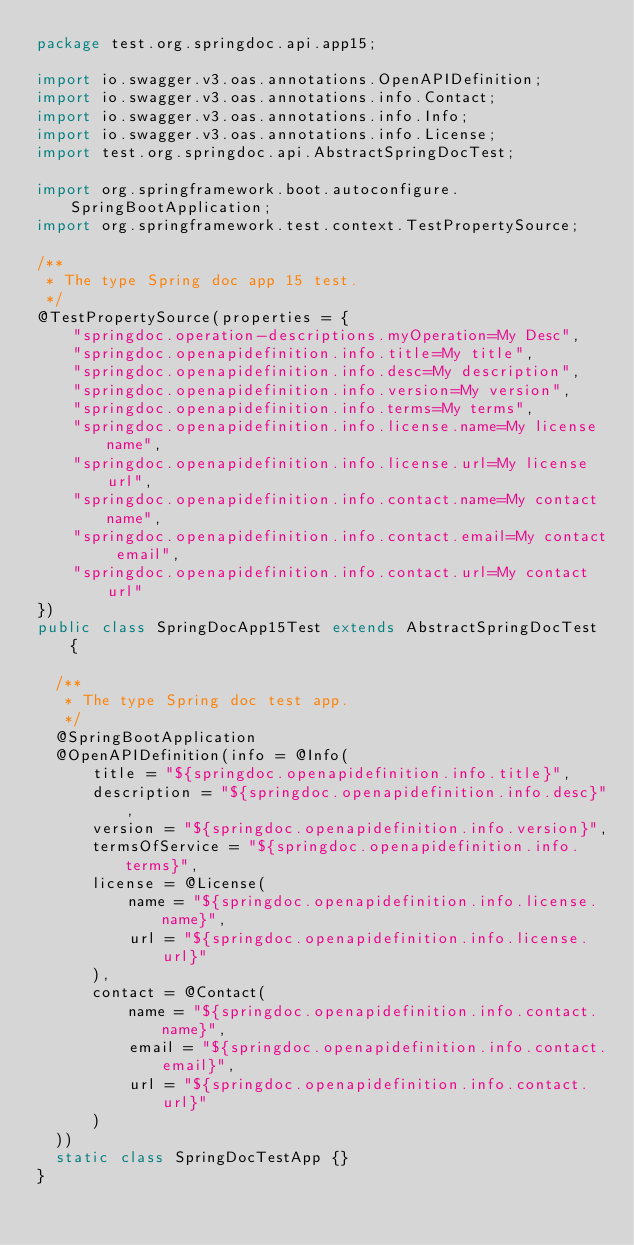<code> <loc_0><loc_0><loc_500><loc_500><_Java_>package test.org.springdoc.api.app15;

import io.swagger.v3.oas.annotations.OpenAPIDefinition;
import io.swagger.v3.oas.annotations.info.Contact;
import io.swagger.v3.oas.annotations.info.Info;
import io.swagger.v3.oas.annotations.info.License;
import test.org.springdoc.api.AbstractSpringDocTest;

import org.springframework.boot.autoconfigure.SpringBootApplication;
import org.springframework.test.context.TestPropertySource;

/**
 * The type Spring doc app 15 test.
 */
@TestPropertySource(properties = {
		"springdoc.operation-descriptions.myOperation=My Desc",
		"springdoc.openapidefinition.info.title=My title",
		"springdoc.openapidefinition.info.desc=My description",
		"springdoc.openapidefinition.info.version=My version",
		"springdoc.openapidefinition.info.terms=My terms",
		"springdoc.openapidefinition.info.license.name=My license name",
		"springdoc.openapidefinition.info.license.url=My license url",
		"springdoc.openapidefinition.info.contact.name=My contact name",
		"springdoc.openapidefinition.info.contact.email=My contact email",
		"springdoc.openapidefinition.info.contact.url=My contact url"
})
public class SpringDocApp15Test extends AbstractSpringDocTest {

	/**
	 * The type Spring doc test app.
	 */
	@SpringBootApplication
	@OpenAPIDefinition(info = @Info(
			title = "${springdoc.openapidefinition.info.title}",
			description = "${springdoc.openapidefinition.info.desc}",
			version = "${springdoc.openapidefinition.info.version}",
			termsOfService = "${springdoc.openapidefinition.info.terms}",
			license = @License(
					name = "${springdoc.openapidefinition.info.license.name}",
					url = "${springdoc.openapidefinition.info.license.url}"
			),
			contact = @Contact(
					name = "${springdoc.openapidefinition.info.contact.name}",
					email = "${springdoc.openapidefinition.info.contact.email}",
					url = "${springdoc.openapidefinition.info.contact.url}"
			)
	))
	static class SpringDocTestApp {}
}
</code> 